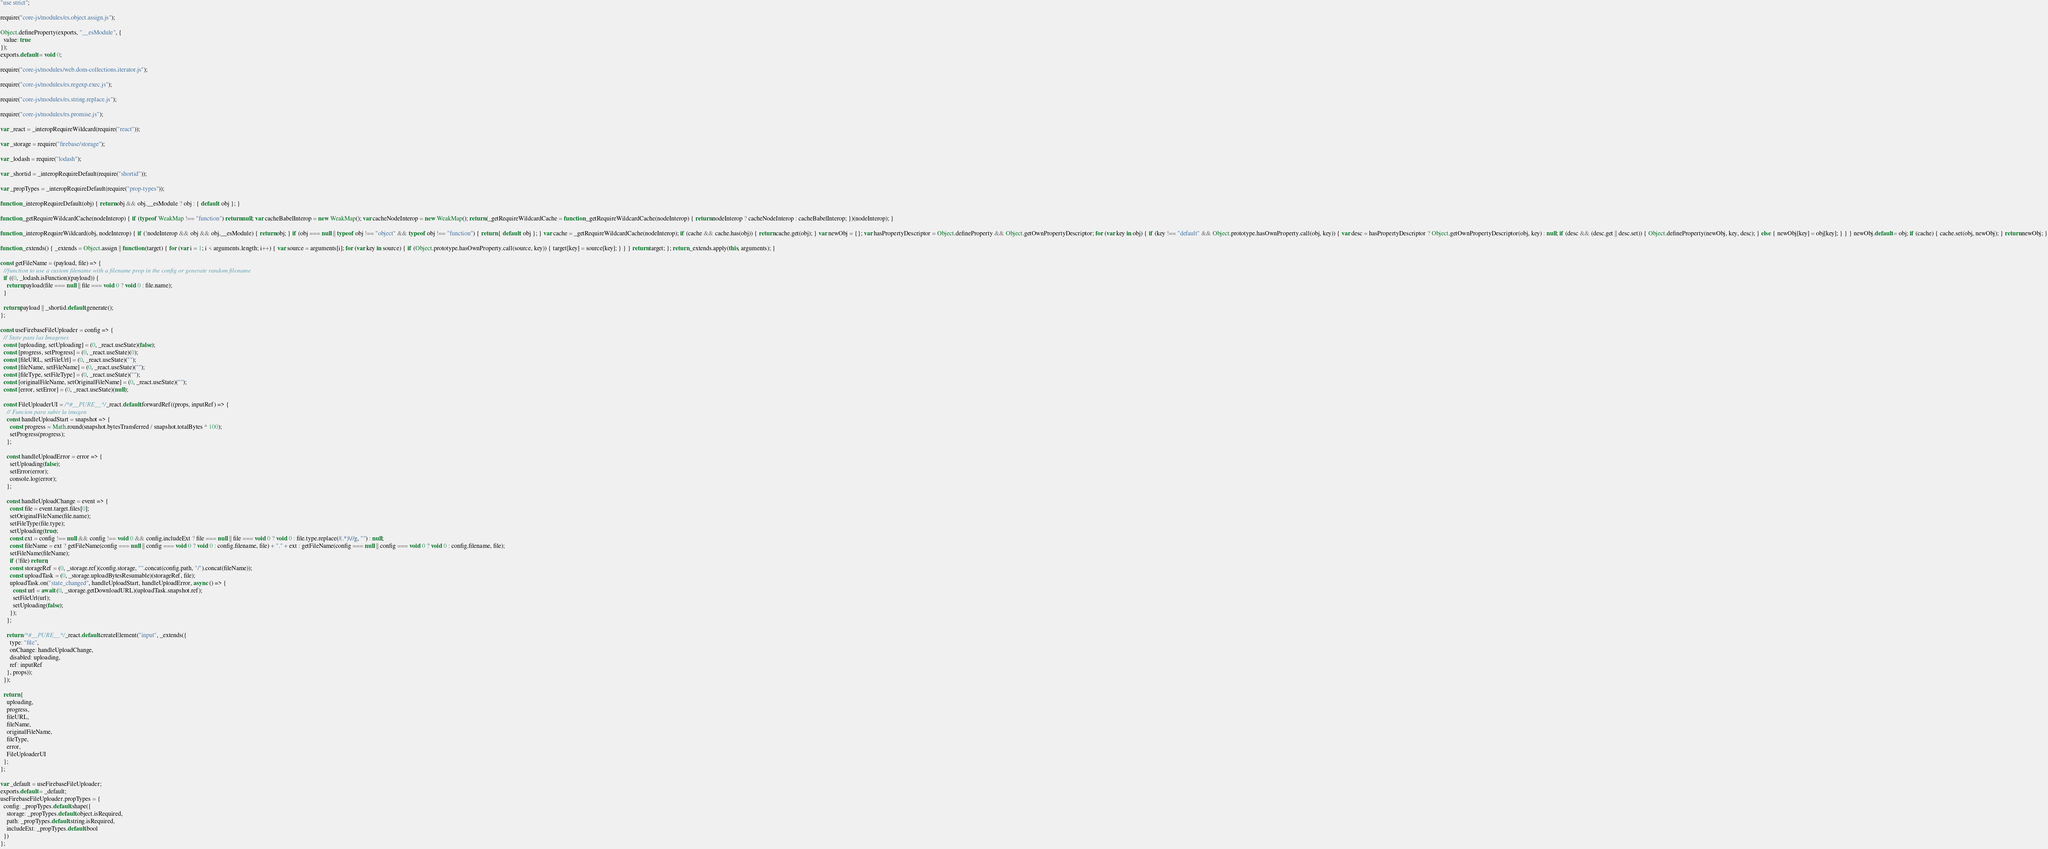<code> <loc_0><loc_0><loc_500><loc_500><_JavaScript_>"use strict";

require("core-js/modules/es.object.assign.js");

Object.defineProperty(exports, "__esModule", {
  value: true
});
exports.default = void 0;

require("core-js/modules/web.dom-collections.iterator.js");

require("core-js/modules/es.regexp.exec.js");

require("core-js/modules/es.string.replace.js");

require("core-js/modules/es.promise.js");

var _react = _interopRequireWildcard(require("react"));

var _storage = require("firebase/storage");

var _lodash = require("lodash");

var _shortid = _interopRequireDefault(require("shortid"));

var _propTypes = _interopRequireDefault(require("prop-types"));

function _interopRequireDefault(obj) { return obj && obj.__esModule ? obj : { default: obj }; }

function _getRequireWildcardCache(nodeInterop) { if (typeof WeakMap !== "function") return null; var cacheBabelInterop = new WeakMap(); var cacheNodeInterop = new WeakMap(); return (_getRequireWildcardCache = function _getRequireWildcardCache(nodeInterop) { return nodeInterop ? cacheNodeInterop : cacheBabelInterop; })(nodeInterop); }

function _interopRequireWildcard(obj, nodeInterop) { if (!nodeInterop && obj && obj.__esModule) { return obj; } if (obj === null || typeof obj !== "object" && typeof obj !== "function") { return { default: obj }; } var cache = _getRequireWildcardCache(nodeInterop); if (cache && cache.has(obj)) { return cache.get(obj); } var newObj = {}; var hasPropertyDescriptor = Object.defineProperty && Object.getOwnPropertyDescriptor; for (var key in obj) { if (key !== "default" && Object.prototype.hasOwnProperty.call(obj, key)) { var desc = hasPropertyDescriptor ? Object.getOwnPropertyDescriptor(obj, key) : null; if (desc && (desc.get || desc.set)) { Object.defineProperty(newObj, key, desc); } else { newObj[key] = obj[key]; } } } newObj.default = obj; if (cache) { cache.set(obj, newObj); } return newObj; }

function _extends() { _extends = Object.assign || function (target) { for (var i = 1; i < arguments.length; i++) { var source = arguments[i]; for (var key in source) { if (Object.prototype.hasOwnProperty.call(source, key)) { target[key] = source[key]; } } } return target; }; return _extends.apply(this, arguments); }

const getFileName = (payload, file) => {
  //function to use a custom filename with a filename prop in the config or generate random filename
  if ((0, _lodash.isFunction)(payload)) {
    return payload(file === null || file === void 0 ? void 0 : file.name);
  }

  return payload || _shortid.default.generate();
};

const useFirebaseFileUploader = config => {
  // State para las Imagenes
  const [uploading, setUploading] = (0, _react.useState)(false);
  const [progress, setProgress] = (0, _react.useState)(0);
  const [fileURL, setFileUrl] = (0, _react.useState)("");
  const [fileName, setFileName] = (0, _react.useState)("");
  const [fileType, setFileType] = (0, _react.useState)("");
  const [originalFileName, setOriginalFileName] = (0, _react.useState)("");
  const [error, setError] = (0, _react.useState)(null);

  const FileUploaderUI = /*#__PURE__*/_react.default.forwardRef((props, inputRef) => {
    // Funcion para subir la imagen
    const handleUploadStart = snapshot => {
      const progress = Math.round(snapshot.bytesTransferred / snapshot.totalBytes * 100);
      setProgress(progress);
    };

    const handleUploadError = error => {
      setUploading(false);
      setError(error);
      console.log(error);
    };

    const handleUploadChange = event => {
      const file = event.target.files[0];
      setOriginalFileName(file.name);
      setFileType(file.type);
      setUploading(true);
      const ext = config !== null && config !== void 0 && config.includeExt ? file === null || file === void 0 ? void 0 : file.type.replace(/(.*)\//g, "") : null;
      const fileName = ext ? getFileName(config === null || config === void 0 ? void 0 : config.filename, file) + "." + ext : getFileName(config === null || config === void 0 ? void 0 : config.filename, file);
      setFileName(fileName);
      if (!file) return;
      const storageRef = (0, _storage.ref)(config.storage, "".concat(config.path, "/").concat(fileName));
      const uploadTask = (0, _storage.uploadBytesResumable)(storageRef, file);
      uploadTask.on("state_changed", handleUploadStart, handleUploadError, async () => {
        const url = await (0, _storage.getDownloadURL)(uploadTask.snapshot.ref);
        setFileUrl(url);
        setUploading(false);
      });
    };

    return /*#__PURE__*/_react.default.createElement("input", _extends({
      type: "file",
      onChange: handleUploadChange,
      disabled: uploading,
      ref: inputRef
    }, props));
  });

  return {
    uploading,
    progress,
    fileURL,
    fileName,
    originalFileName,
    fileType,
    error,
    FileUploaderUI
  };
};

var _default = useFirebaseFileUploader;
exports.default = _default;
useFirebaseFileUploader.propTypes = {
  config: _propTypes.default.shape({
    storage: _propTypes.default.object.isRequired,
    path: _propTypes.default.string.isRequired,
    includeExt: _propTypes.default.bool
  })
};</code> 